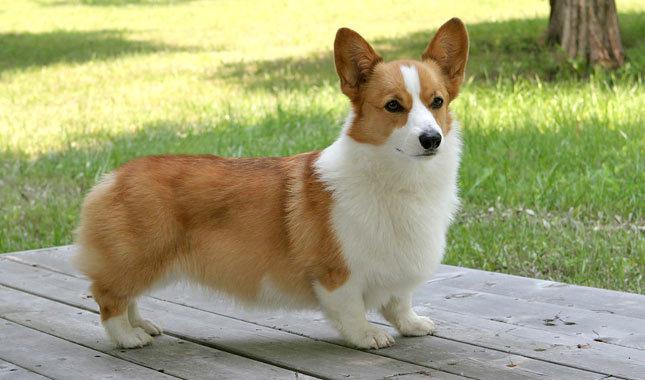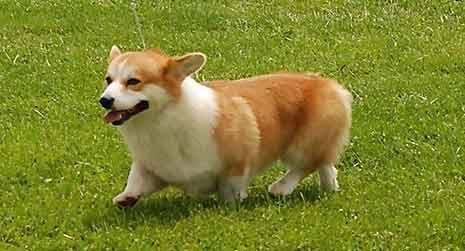The first image is the image on the left, the second image is the image on the right. Analyze the images presented: Is the assertion "The dog in the image on the left is facing right" valid? Answer yes or no. Yes. The first image is the image on the left, the second image is the image on the right. For the images displayed, is the sentence "Left image shows a corgi dog standing with body turned rightward." factually correct? Answer yes or no. Yes. 